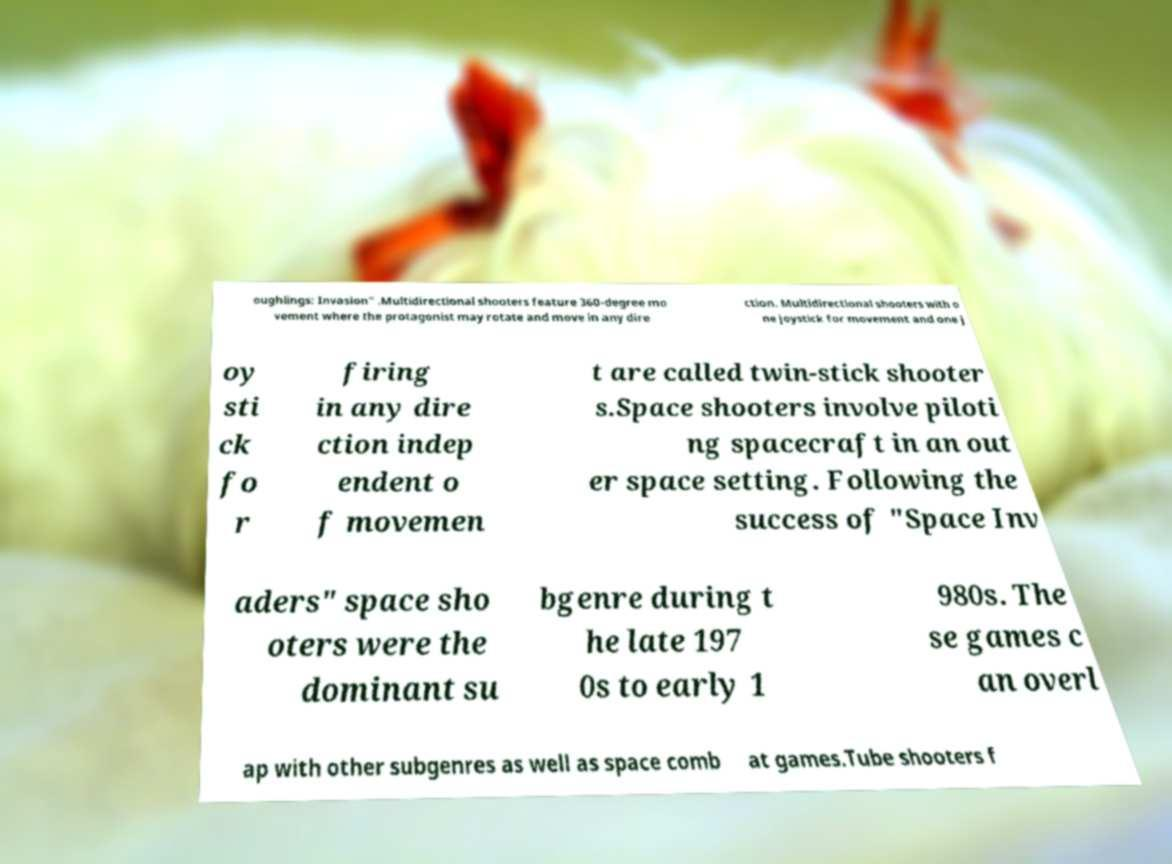Can you accurately transcribe the text from the provided image for me? oughlings: Invasion" .Multidirectional shooters feature 360-degree mo vement where the protagonist may rotate and move in any dire ction. Multidirectional shooters with o ne joystick for movement and one j oy sti ck fo r firing in any dire ction indep endent o f movemen t are called twin-stick shooter s.Space shooters involve piloti ng spacecraft in an out er space setting. Following the success of "Space Inv aders" space sho oters were the dominant su bgenre during t he late 197 0s to early 1 980s. The se games c an overl ap with other subgenres as well as space comb at games.Tube shooters f 